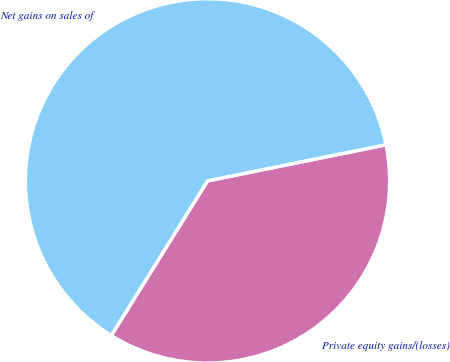<chart> <loc_0><loc_0><loc_500><loc_500><pie_chart><fcel>Private equity gains/(losses)<fcel>Net gains on sales of<nl><fcel>37.04%<fcel>62.96%<nl></chart> 